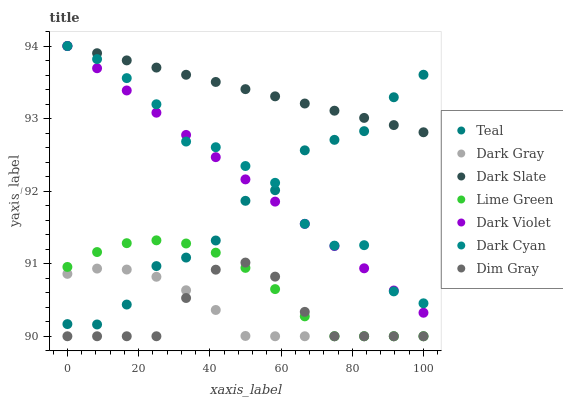Does Dim Gray have the minimum area under the curve?
Answer yes or no. Yes. Does Dark Slate have the maximum area under the curve?
Answer yes or no. Yes. Does Dark Violet have the minimum area under the curve?
Answer yes or no. No. Does Dark Violet have the maximum area under the curve?
Answer yes or no. No. Is Dark Violet the smoothest?
Answer yes or no. Yes. Is Teal the roughest?
Answer yes or no. Yes. Is Dark Gray the smoothest?
Answer yes or no. No. Is Dark Gray the roughest?
Answer yes or no. No. Does Dim Gray have the lowest value?
Answer yes or no. Yes. Does Dark Violet have the lowest value?
Answer yes or no. No. Does Dark Cyan have the highest value?
Answer yes or no. Yes. Does Dark Gray have the highest value?
Answer yes or no. No. Is Dark Gray less than Dark Cyan?
Answer yes or no. Yes. Is Dark Violet greater than Lime Green?
Answer yes or no. Yes. Does Dim Gray intersect Dark Gray?
Answer yes or no. Yes. Is Dim Gray less than Dark Gray?
Answer yes or no. No. Is Dim Gray greater than Dark Gray?
Answer yes or no. No. Does Dark Gray intersect Dark Cyan?
Answer yes or no. No. 